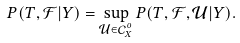<formula> <loc_0><loc_0><loc_500><loc_500>P ( T , \mathcal { F } | Y ) = \sup _ { \mathcal { U } \in \mathcal { C } _ { X } ^ { o } } P ( T , \mathcal { F } , \mathcal { U } | Y ) .</formula> 